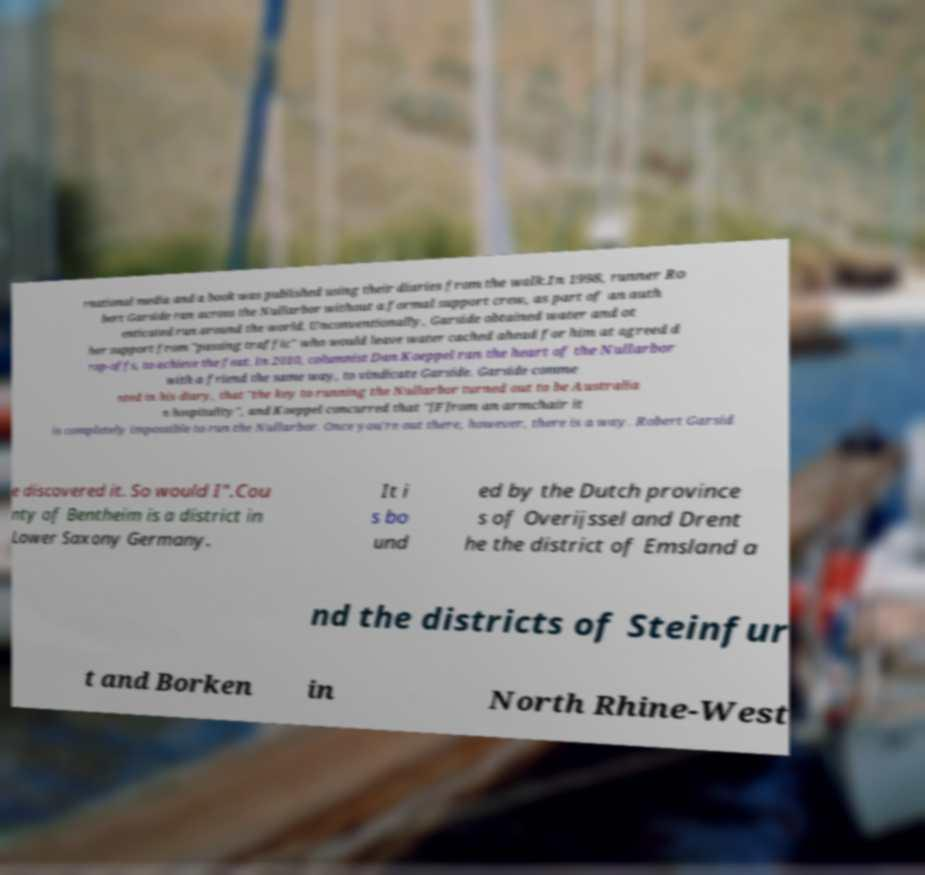Could you assist in decoding the text presented in this image and type it out clearly? rnational media and a book was published using their diaries from the walk.In 1998, runner Ro bert Garside ran across the Nullarbor without a formal support crew, as part of an auth enticated run around the world. Unconventionally, Garside obtained water and ot her support from "passing traffic" who would leave water cached ahead for him at agreed d rop-offs, to achieve the feat. In 2010, columnist Dan Koeppel ran the heart of the Nullarbor with a friend the same way, to vindicate Garside. Garside comme nted in his diary, that "the key to running the Nullarbor turned out to be Australia n hospitality", and Koeppel concurred that "[F]rom an armchair it is completely impossible to run the Nullarbor. Once you're out there, however, there is a way. Robert Garsid e discovered it. So would I".Cou nty of Bentheim is a district in Lower Saxony Germany. It i s bo und ed by the Dutch province s of Overijssel and Drent he the district of Emsland a nd the districts of Steinfur t and Borken in North Rhine-West 